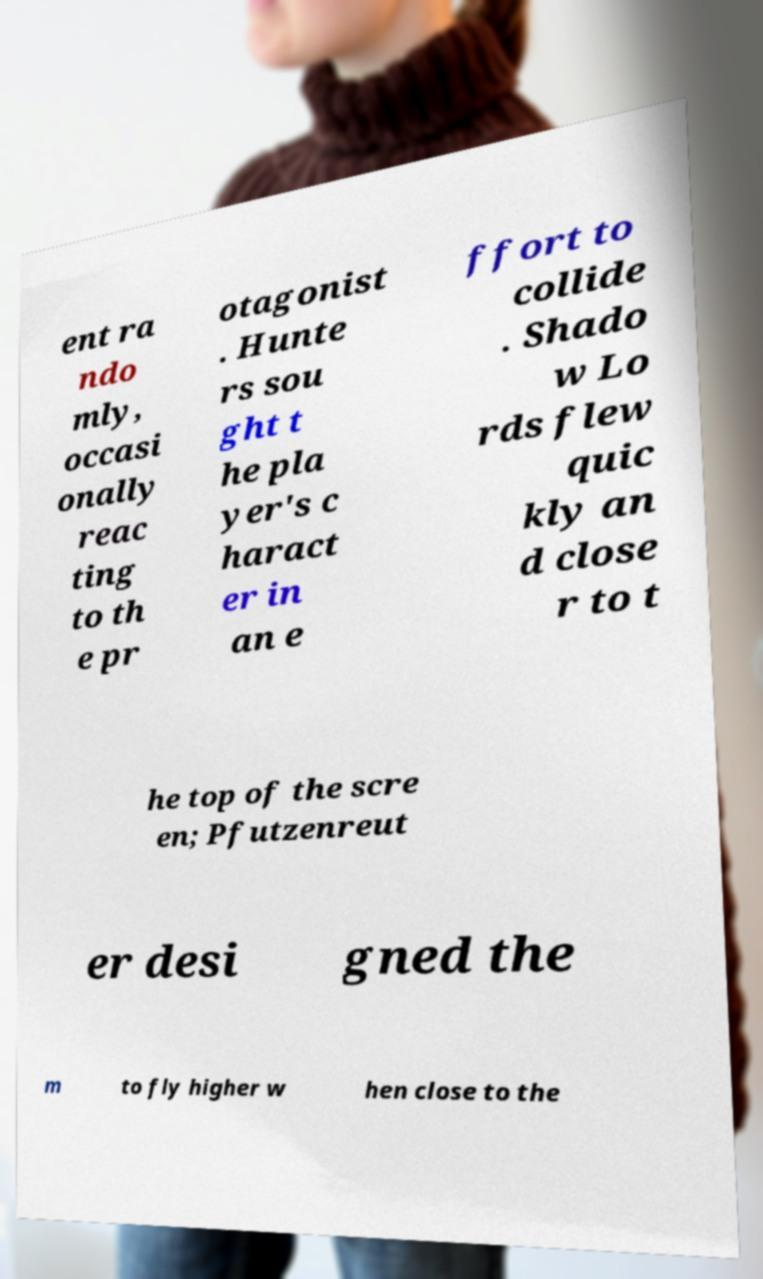I need the written content from this picture converted into text. Can you do that? ent ra ndo mly, occasi onally reac ting to th e pr otagonist . Hunte rs sou ght t he pla yer's c haract er in an e ffort to collide . Shado w Lo rds flew quic kly an d close r to t he top of the scre en; Pfutzenreut er desi gned the m to fly higher w hen close to the 